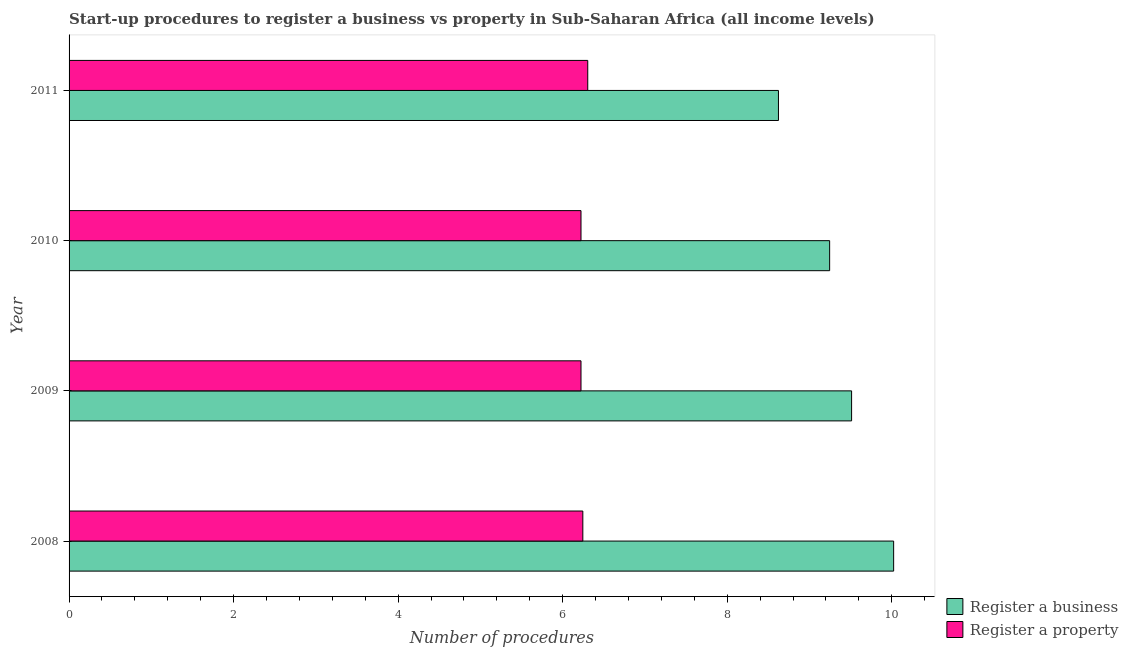Are the number of bars per tick equal to the number of legend labels?
Provide a succinct answer. Yes. How many bars are there on the 3rd tick from the bottom?
Your answer should be very brief. 2. In how many cases, is the number of bars for a given year not equal to the number of legend labels?
Provide a short and direct response. 0. What is the number of procedures to register a property in 2010?
Ensure brevity in your answer.  6.22. Across all years, what is the maximum number of procedures to register a property?
Give a very brief answer. 6.3. Across all years, what is the minimum number of procedures to register a property?
Your response must be concise. 6.22. In which year was the number of procedures to register a property maximum?
Provide a short and direct response. 2011. What is the total number of procedures to register a business in the graph?
Give a very brief answer. 37.4. What is the difference between the number of procedures to register a property in 2008 and that in 2009?
Offer a very short reply. 0.02. What is the difference between the number of procedures to register a business in 2009 and the number of procedures to register a property in 2008?
Provide a succinct answer. 3.27. What is the average number of procedures to register a property per year?
Ensure brevity in your answer.  6.25. In the year 2009, what is the difference between the number of procedures to register a business and number of procedures to register a property?
Give a very brief answer. 3.29. What is the ratio of the number of procedures to register a property in 2010 to that in 2011?
Give a very brief answer. 0.99. What is the difference between the highest and the second highest number of procedures to register a property?
Keep it short and to the point. 0.06. What is the difference between the highest and the lowest number of procedures to register a property?
Your response must be concise. 0.08. In how many years, is the number of procedures to register a property greater than the average number of procedures to register a property taken over all years?
Keep it short and to the point. 1. What does the 2nd bar from the top in 2011 represents?
Keep it short and to the point. Register a business. What does the 1st bar from the bottom in 2008 represents?
Give a very brief answer. Register a business. How many years are there in the graph?
Your answer should be very brief. 4. What is the difference between two consecutive major ticks on the X-axis?
Your answer should be compact. 2. How many legend labels are there?
Offer a terse response. 2. How are the legend labels stacked?
Ensure brevity in your answer.  Vertical. What is the title of the graph?
Your answer should be very brief. Start-up procedures to register a business vs property in Sub-Saharan Africa (all income levels). What is the label or title of the X-axis?
Make the answer very short. Number of procedures. What is the label or title of the Y-axis?
Provide a short and direct response. Year. What is the Number of procedures in Register a business in 2008?
Make the answer very short. 10.02. What is the Number of procedures of Register a property in 2008?
Offer a terse response. 6.24. What is the Number of procedures of Register a business in 2009?
Keep it short and to the point. 9.51. What is the Number of procedures of Register a property in 2009?
Offer a very short reply. 6.22. What is the Number of procedures of Register a business in 2010?
Keep it short and to the point. 9.24. What is the Number of procedures in Register a property in 2010?
Offer a terse response. 6.22. What is the Number of procedures of Register a business in 2011?
Offer a very short reply. 8.62. What is the Number of procedures in Register a property in 2011?
Offer a very short reply. 6.3. Across all years, what is the maximum Number of procedures in Register a business?
Your answer should be very brief. 10.02. Across all years, what is the maximum Number of procedures in Register a property?
Keep it short and to the point. 6.3. Across all years, what is the minimum Number of procedures of Register a business?
Provide a succinct answer. 8.62. Across all years, what is the minimum Number of procedures in Register a property?
Provide a short and direct response. 6.22. What is the total Number of procedures of Register a business in the graph?
Offer a terse response. 37.4. What is the total Number of procedures in Register a property in the graph?
Provide a short and direct response. 24.99. What is the difference between the Number of procedures of Register a business in 2008 and that in 2009?
Give a very brief answer. 0.51. What is the difference between the Number of procedures in Register a property in 2008 and that in 2009?
Make the answer very short. 0.02. What is the difference between the Number of procedures in Register a business in 2008 and that in 2010?
Your answer should be compact. 0.78. What is the difference between the Number of procedures in Register a property in 2008 and that in 2010?
Keep it short and to the point. 0.02. What is the difference between the Number of procedures of Register a property in 2008 and that in 2011?
Make the answer very short. -0.06. What is the difference between the Number of procedures of Register a business in 2009 and that in 2010?
Keep it short and to the point. 0.27. What is the difference between the Number of procedures of Register a business in 2009 and that in 2011?
Keep it short and to the point. 0.89. What is the difference between the Number of procedures of Register a property in 2009 and that in 2011?
Keep it short and to the point. -0.08. What is the difference between the Number of procedures of Register a business in 2010 and that in 2011?
Keep it short and to the point. 0.62. What is the difference between the Number of procedures in Register a property in 2010 and that in 2011?
Offer a very short reply. -0.08. What is the difference between the Number of procedures of Register a business in 2008 and the Number of procedures of Register a property in 2009?
Give a very brief answer. 3.8. What is the difference between the Number of procedures in Register a business in 2008 and the Number of procedures in Register a property in 2010?
Make the answer very short. 3.8. What is the difference between the Number of procedures of Register a business in 2008 and the Number of procedures of Register a property in 2011?
Provide a succinct answer. 3.72. What is the difference between the Number of procedures of Register a business in 2009 and the Number of procedures of Register a property in 2010?
Offer a very short reply. 3.29. What is the difference between the Number of procedures of Register a business in 2009 and the Number of procedures of Register a property in 2011?
Give a very brief answer. 3.21. What is the difference between the Number of procedures of Register a business in 2010 and the Number of procedures of Register a property in 2011?
Your answer should be very brief. 2.94. What is the average Number of procedures in Register a business per year?
Offer a very short reply. 9.35. What is the average Number of procedures in Register a property per year?
Offer a terse response. 6.25. In the year 2008, what is the difference between the Number of procedures in Register a business and Number of procedures in Register a property?
Give a very brief answer. 3.78. In the year 2009, what is the difference between the Number of procedures in Register a business and Number of procedures in Register a property?
Your answer should be very brief. 3.29. In the year 2010, what is the difference between the Number of procedures of Register a business and Number of procedures of Register a property?
Provide a succinct answer. 3.02. In the year 2011, what is the difference between the Number of procedures of Register a business and Number of procedures of Register a property?
Offer a terse response. 2.32. What is the ratio of the Number of procedures of Register a business in 2008 to that in 2009?
Offer a terse response. 1.05. What is the ratio of the Number of procedures of Register a property in 2008 to that in 2009?
Provide a short and direct response. 1. What is the ratio of the Number of procedures of Register a business in 2008 to that in 2010?
Offer a very short reply. 1.08. What is the ratio of the Number of procedures of Register a property in 2008 to that in 2010?
Provide a short and direct response. 1. What is the ratio of the Number of procedures of Register a business in 2008 to that in 2011?
Your response must be concise. 1.16. What is the ratio of the Number of procedures in Register a business in 2009 to that in 2010?
Provide a short and direct response. 1.03. What is the ratio of the Number of procedures in Register a property in 2009 to that in 2010?
Make the answer very short. 1. What is the ratio of the Number of procedures of Register a business in 2009 to that in 2011?
Keep it short and to the point. 1.1. What is the ratio of the Number of procedures in Register a business in 2010 to that in 2011?
Keep it short and to the point. 1.07. What is the difference between the highest and the second highest Number of procedures in Register a business?
Ensure brevity in your answer.  0.51. What is the difference between the highest and the second highest Number of procedures of Register a property?
Provide a short and direct response. 0.06. What is the difference between the highest and the lowest Number of procedures of Register a property?
Provide a succinct answer. 0.08. 